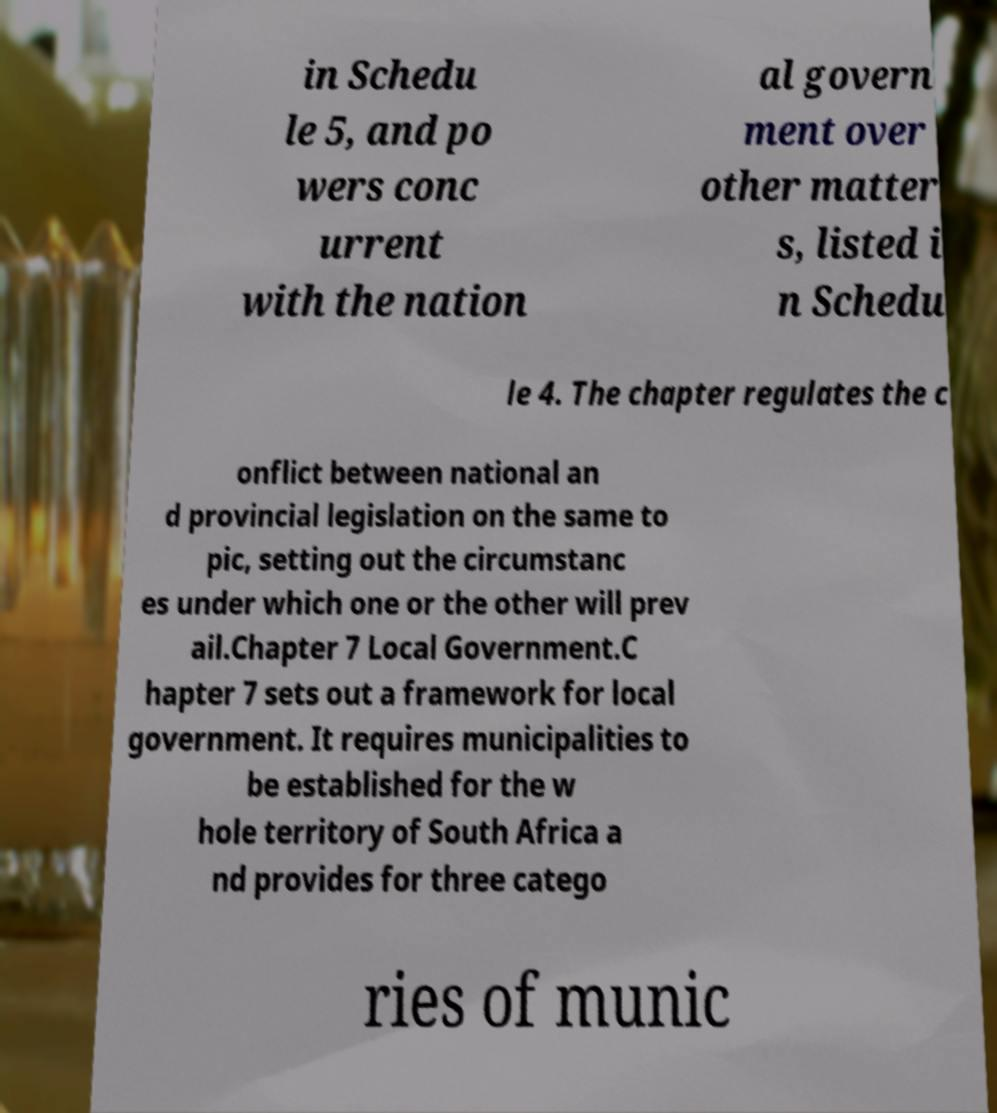Please read and relay the text visible in this image. What does it say? in Schedu le 5, and po wers conc urrent with the nation al govern ment over other matter s, listed i n Schedu le 4. The chapter regulates the c onflict between national an d provincial legislation on the same to pic, setting out the circumstanc es under which one or the other will prev ail.Chapter 7 Local Government.C hapter 7 sets out a framework for local government. It requires municipalities to be established for the w hole territory of South Africa a nd provides for three catego ries of munic 